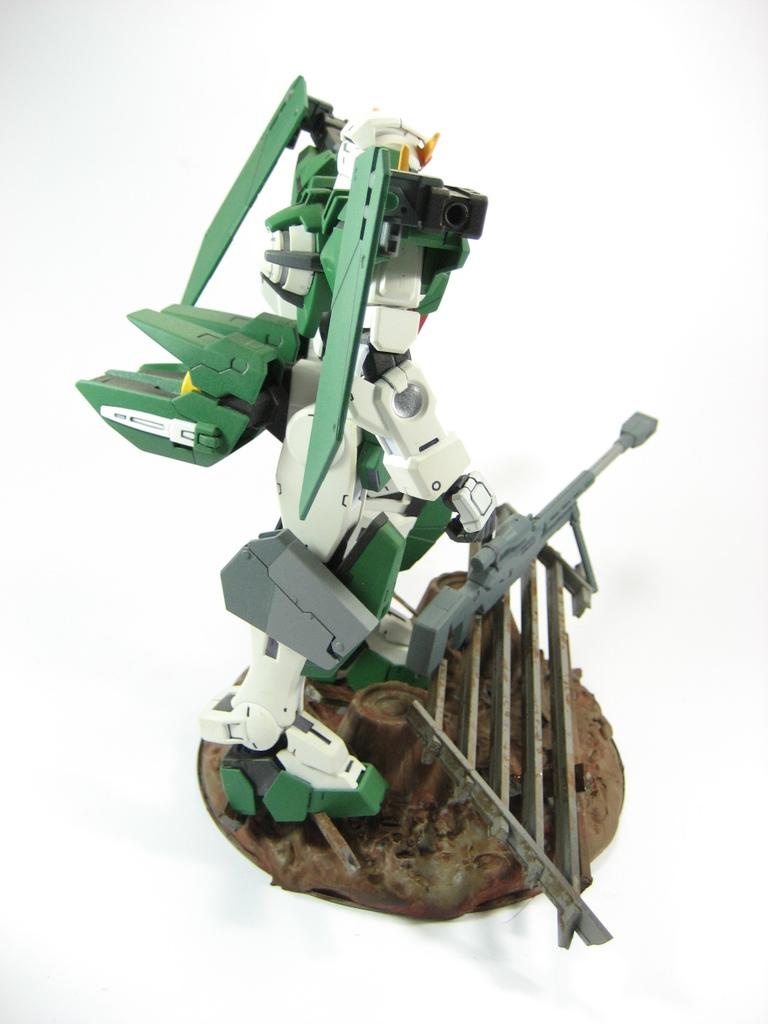What is the main subject of the image? The main subject of the image is a robot toy. Can you describe the colors of the robot toy? The robot toy has multiple colors, including white, green, grey, black, and brown. What is the color of the background in the image? The background of the image is white. What type of cakes is the boy reading about in the image? There is no boy or cakes present in the image; it features a robot toy with multiple colors against a white background. 